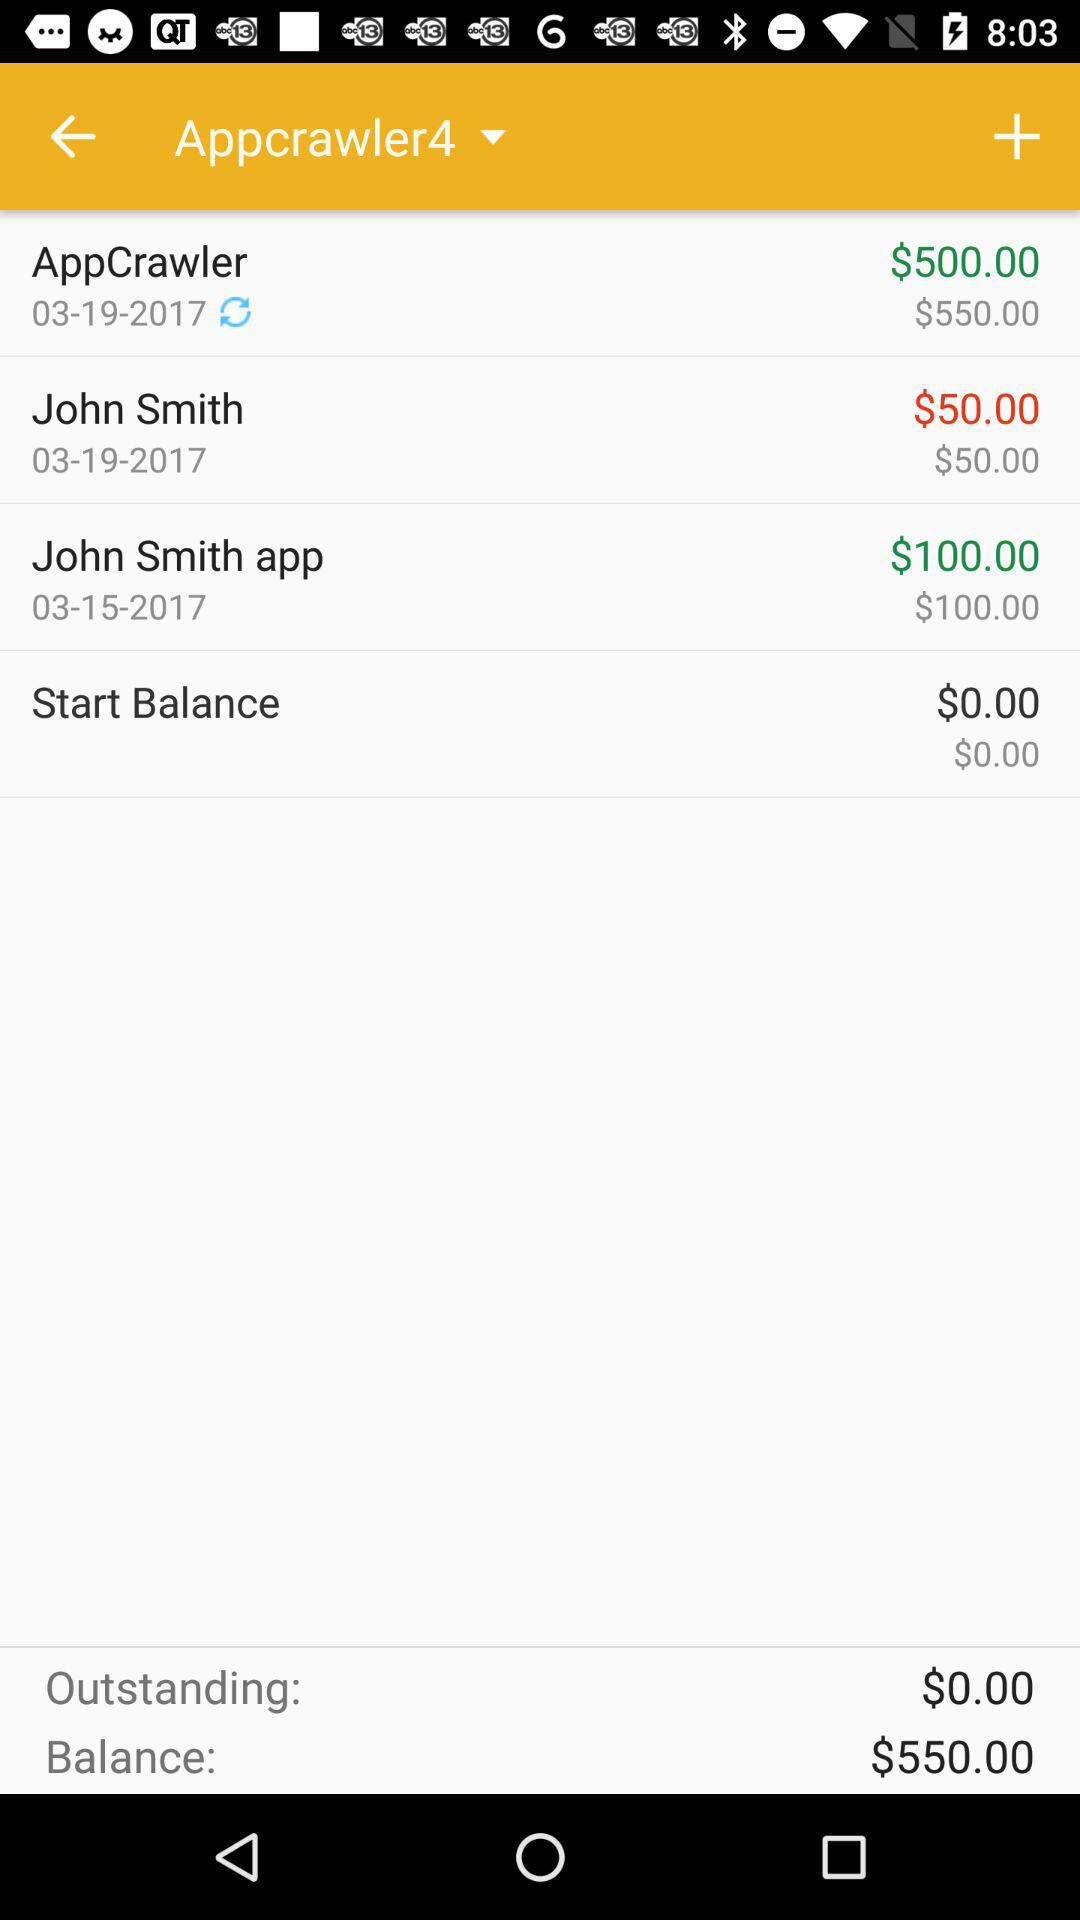Which user is selected? The selected user is "Appcrawler4". 